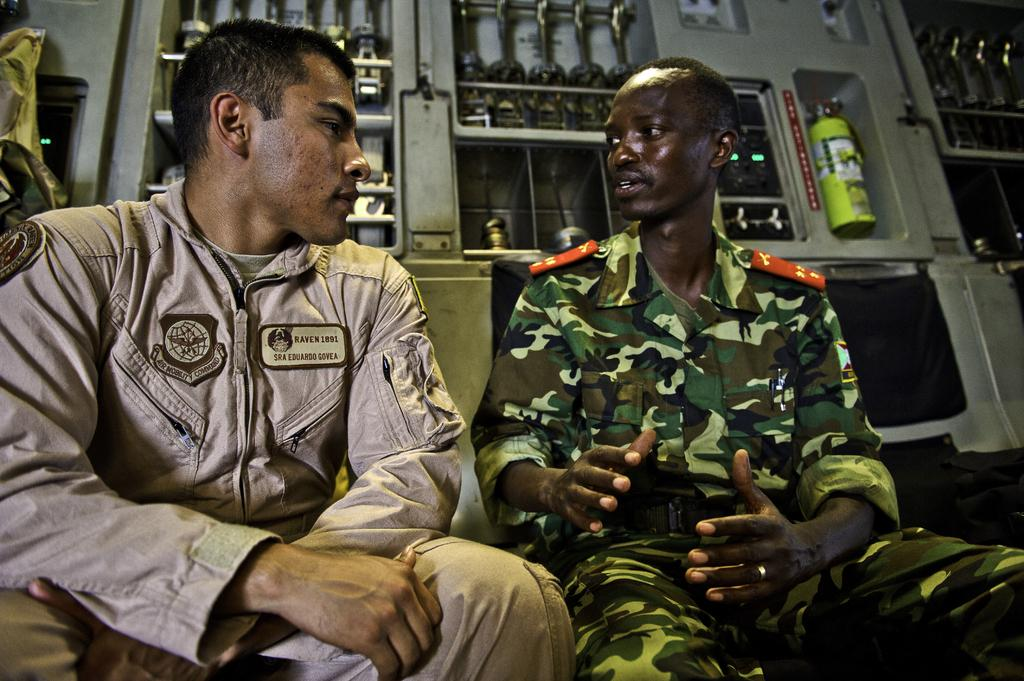How many Army personnel are in the image? There are two Army personnel in the image. What are the Army personnel doing in the image? The Army personnel are sitting and talking with each other. Can you describe the background of the image? There are arms visible in the background of the image. What year is depicted in the image? The year is not depicted in the image; there is no indication of a specific time period. 